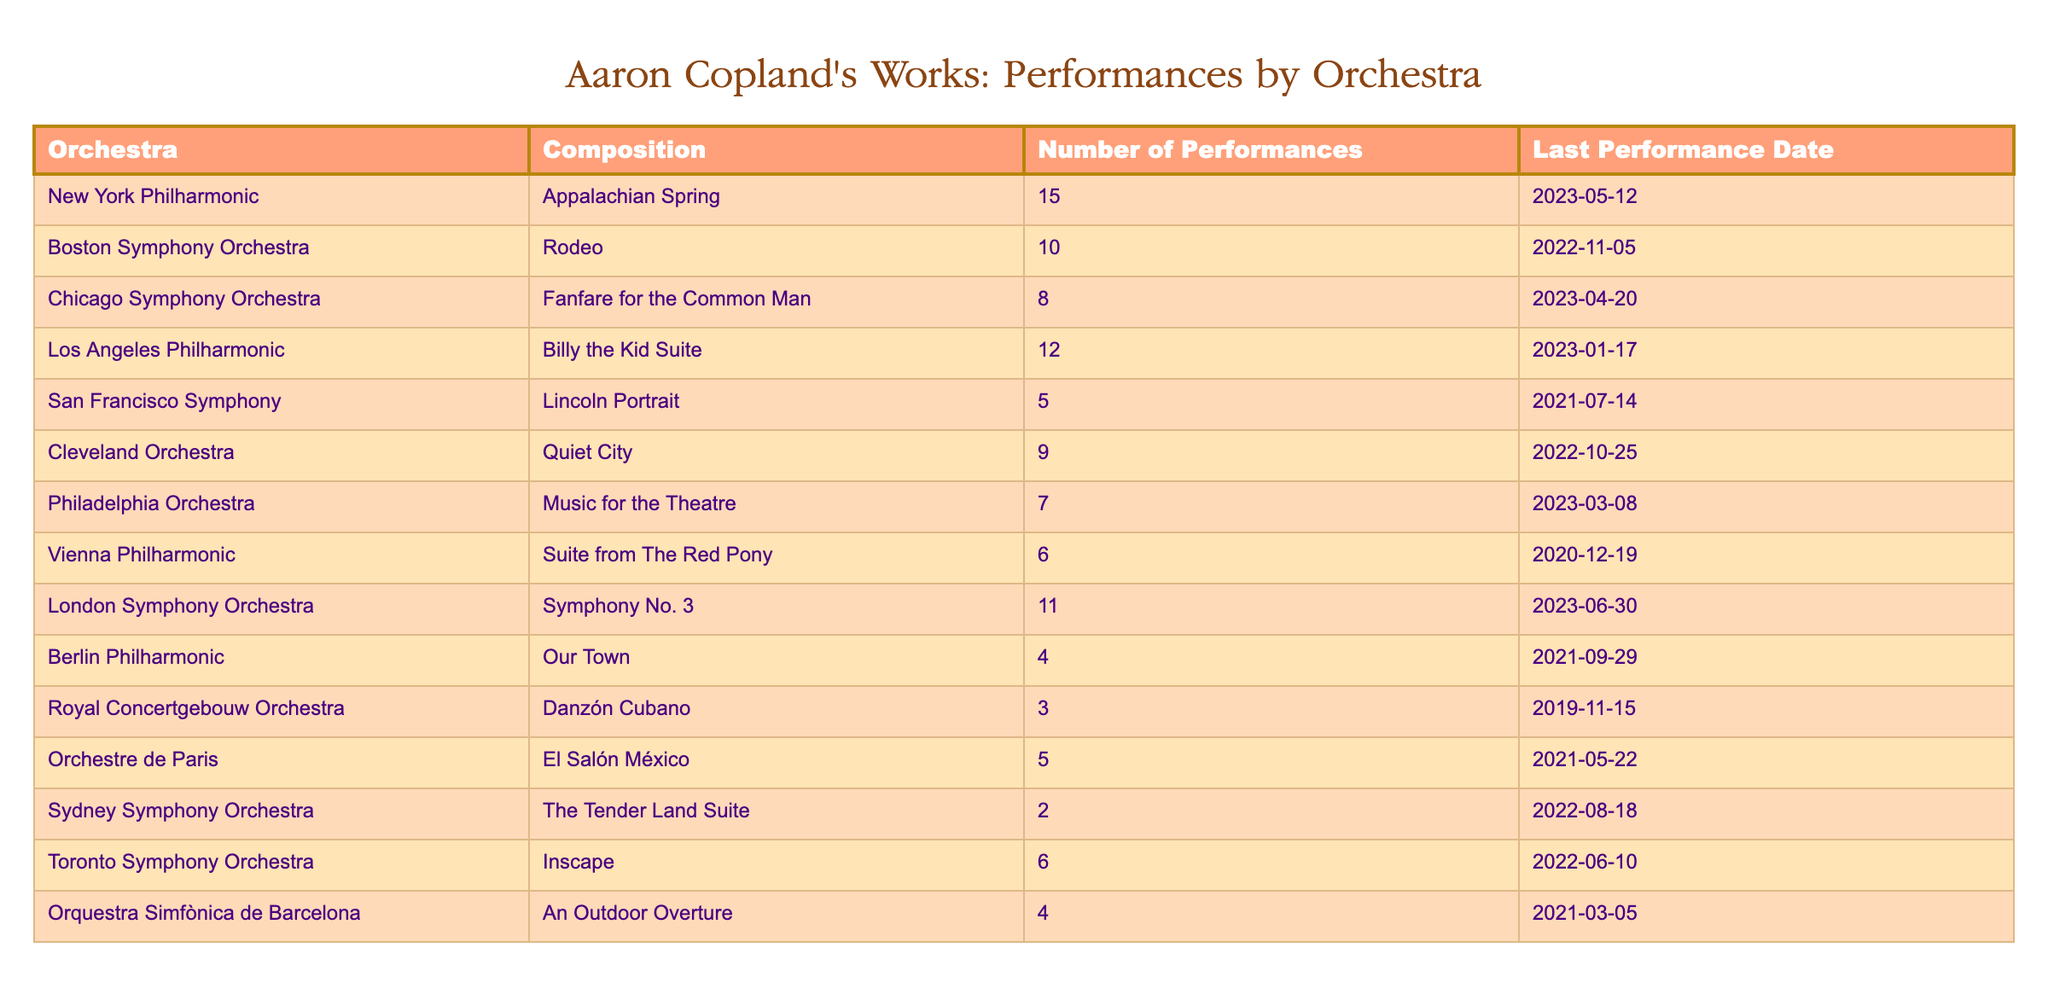What is the highest number of performances for a single composition? The highest number of performances is for "Appalachian Spring," performed by the New York Philharmonic 15 times. This is the greatest value listed in the "Number of Performances" column.
Answer: 15 Which orchestra performed "Rodeo" and how many times? "Rodeo" was performed by the Boston Symphony Orchestra, and it was staged 10 times, as indicated in the table.
Answer: Boston Symphony Orchestra, 10 How many total performances of the works by Aaron Copland were recorded by the Los Angeles Philharmonic? The Los Angeles Philharmonic performed "Billy the Kid Suite" 12 times, and since only one composition is listed for this orchestra, this is the total number of performances recorded.
Answer: 12 Which composition has the least number of performances and how many times was it performed? The composition with the least number of performances is "Danzón Cubano," played by the Royal Concertgebouw Orchestra, with a total of 3 performances, as shown in the table.
Answer: Danzón Cubano, 3 Is the "Berlin Philharmonic" orchestra listed in the table? Yes, the "Berlin Philharmonic" is included in the table, as evidenced by the entry listed under that name.
Answer: Yes Which two orchestras performed "El Salón México" and "Quiet City"? "El Salón México" was performed by the Orchestre de Paris 5 times, while "Quiet City" was performed by the Cleveland Orchestra 9 times. The information is directly pulled from the table for these compositions.
Answer: Orchestre de Paris, Cleveland Orchestra What is the average number of performances across all compositions listed? To find the average, sum the number of performances: 15 + 10 + 8 + 12 + 5 + 9 + 7 + 6 + 4 + 3 + 5 + 2 + 6 + 4 = 82. There are 14 performances listed, so dividing 82 by 14 gives an average of about 5.86.
Answer: Approximately 5.86 Which two compositions had their last performance in 2023 and how many times were they performed? "Appalachian Spring" by the New York Philharmonic was performed 15 times and "Fanfare for the Common Man" by the Chicago Symphony Orchestra was performed 8 times, both having their last performances in 2023, as indicated in their respective entries.
Answer: Appalachian Spring, 15; Fanfare for the Common Man, 8 